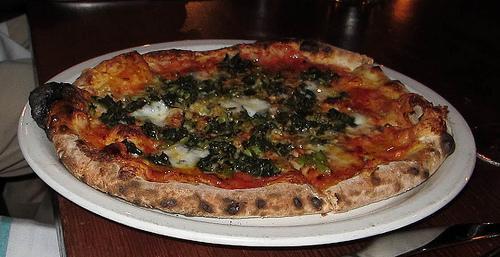How many pizzas are there?
Give a very brief answer. 1. 